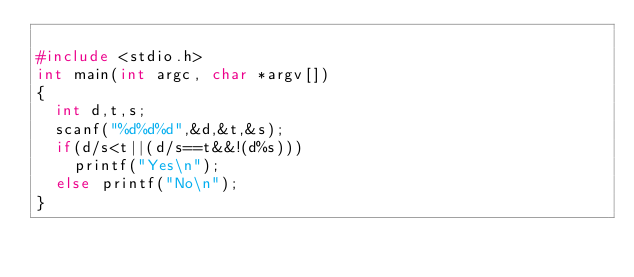Convert code to text. <code><loc_0><loc_0><loc_500><loc_500><_C_>
#include <stdio.h>
int main(int argc, char *argv[])
{
	int d,t,s;
	scanf("%d%d%d",&d,&t,&s);
	if(d/s<t||(d/s==t&&!(d%s)))
		printf("Yes\n");
	else printf("No\n");
}</code> 